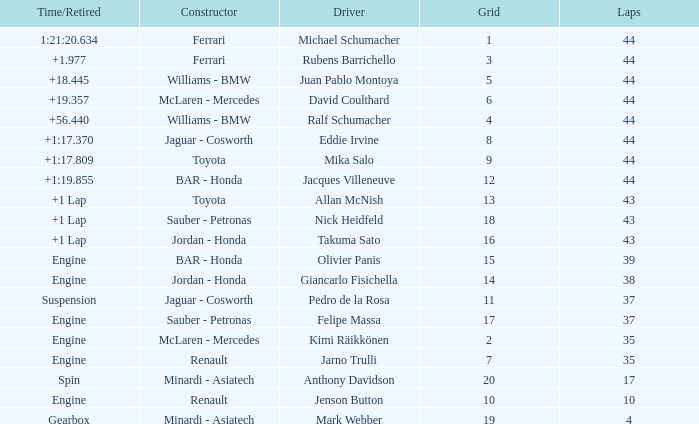Would you mind parsing the complete table? {'header': ['Time/Retired', 'Constructor', 'Driver', 'Grid', 'Laps'], 'rows': [['1:21:20.634', 'Ferrari', 'Michael Schumacher', '1', '44'], ['+1.977', 'Ferrari', 'Rubens Barrichello', '3', '44'], ['+18.445', 'Williams - BMW', 'Juan Pablo Montoya', '5', '44'], ['+19.357', 'McLaren - Mercedes', 'David Coulthard', '6', '44'], ['+56.440', 'Williams - BMW', 'Ralf Schumacher', '4', '44'], ['+1:17.370', 'Jaguar - Cosworth', 'Eddie Irvine', '8', '44'], ['+1:17.809', 'Toyota', 'Mika Salo', '9', '44'], ['+1:19.855', 'BAR - Honda', 'Jacques Villeneuve', '12', '44'], ['+1 Lap', 'Toyota', 'Allan McNish', '13', '43'], ['+1 Lap', 'Sauber - Petronas', 'Nick Heidfeld', '18', '43'], ['+1 Lap', 'Jordan - Honda', 'Takuma Sato', '16', '43'], ['Engine', 'BAR - Honda', 'Olivier Panis', '15', '39'], ['Engine', 'Jordan - Honda', 'Giancarlo Fisichella', '14', '38'], ['Suspension', 'Jaguar - Cosworth', 'Pedro de la Rosa', '11', '37'], ['Engine', 'Sauber - Petronas', 'Felipe Massa', '17', '37'], ['Engine', 'McLaren - Mercedes', 'Kimi Räikkönen', '2', '35'], ['Engine', 'Renault', 'Jarno Trulli', '7', '35'], ['Spin', 'Minardi - Asiatech', 'Anthony Davidson', '20', '17'], ['Engine', 'Renault', 'Jenson Button', '10', '10'], ['Gearbox', 'Minardi - Asiatech', 'Mark Webber', '19', '4']]} What was the retired time on someone who had 43 laps on a grip of 18? +1 Lap. 